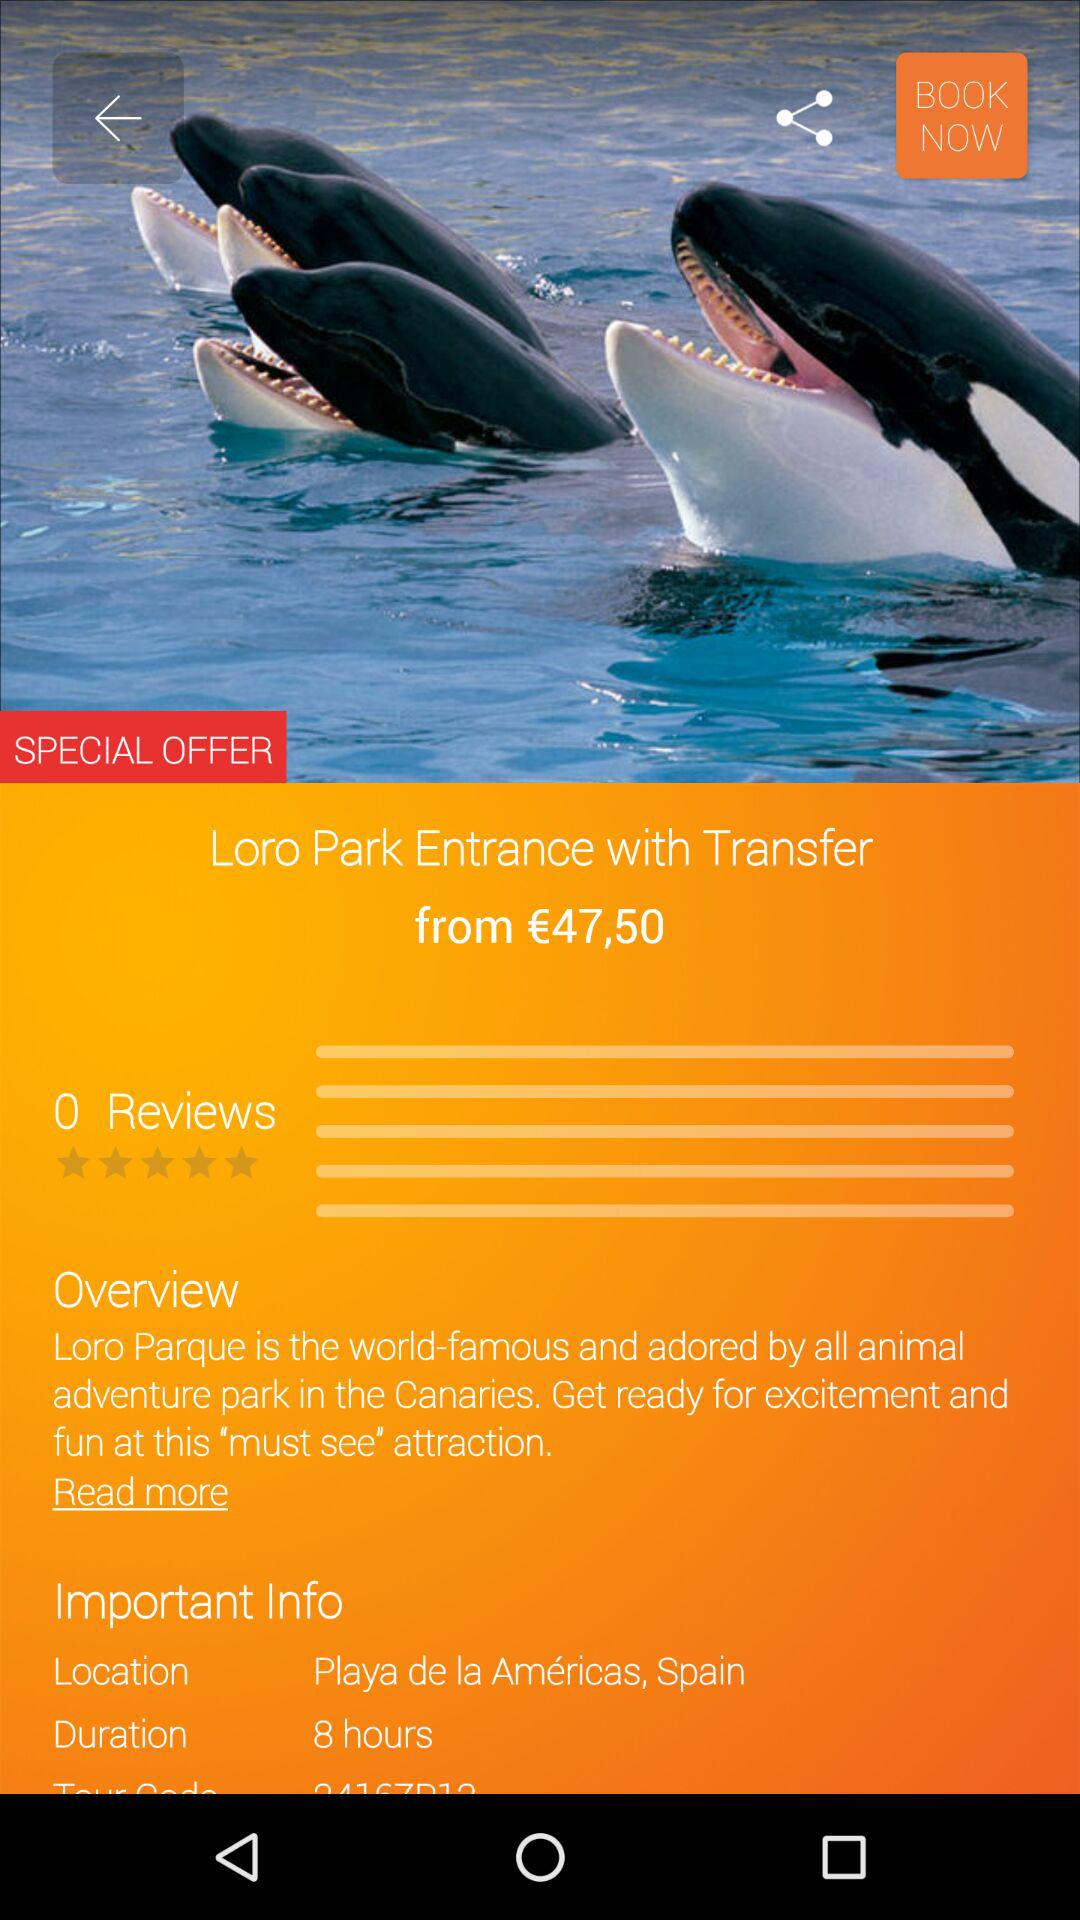What is the number of reviews? The number of reviews is 0. 